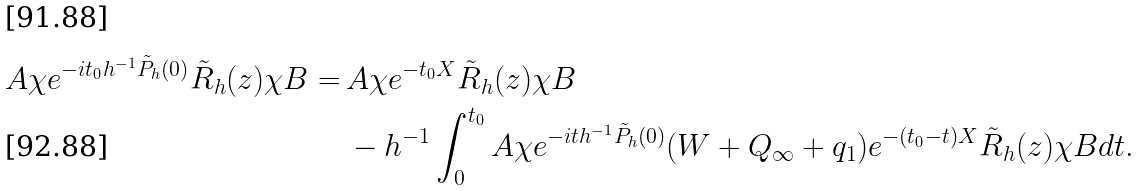<formula> <loc_0><loc_0><loc_500><loc_500>A \chi e ^ { - i t _ { 0 } h ^ { - 1 } \tilde { P } _ { h } ( 0 ) } \tilde { R } _ { h } ( z ) \chi B = & \, A \chi e ^ { - t _ { 0 } X } \tilde { R } _ { h } ( z ) \chi B \\ & \, - h ^ { - 1 } \int _ { 0 } ^ { t _ { 0 } } A \chi e ^ { - i t h ^ { - 1 } \tilde { P } _ { h } ( 0 ) } ( W + Q _ { \infty } + q _ { 1 } ) e ^ { - ( t _ { 0 } - t ) X } \tilde { R } _ { h } ( z ) \chi B d t .</formula> 